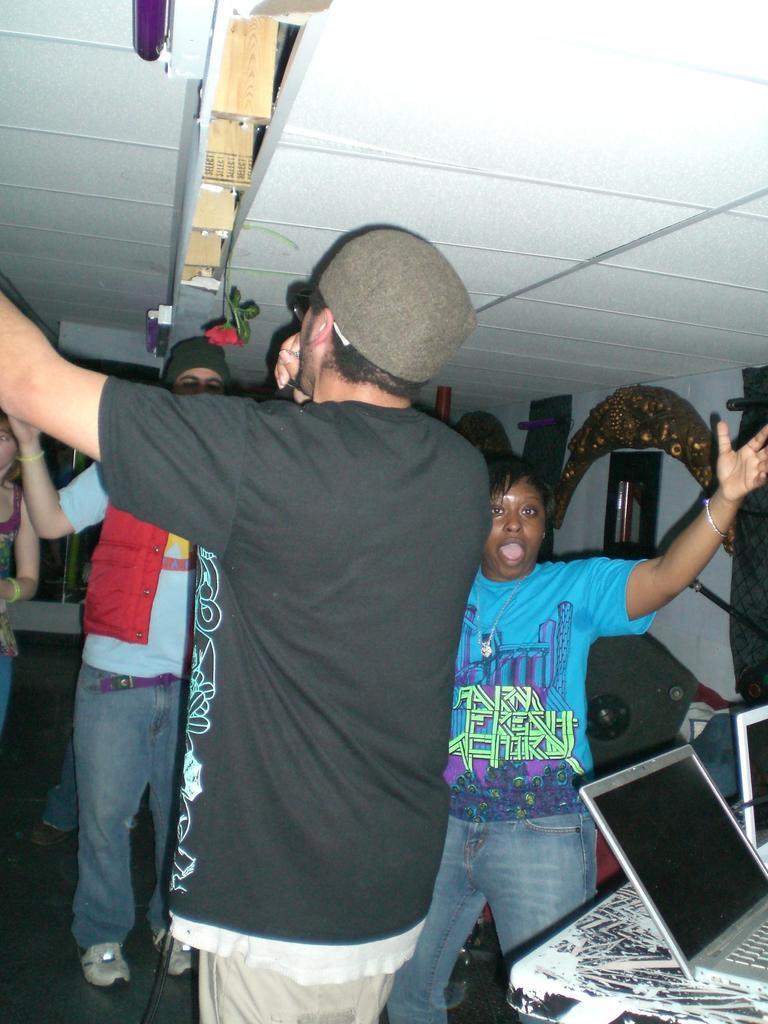Can you describe this image briefly? In this image we can see a few people, on the right side of the image we can see a table with a few laptops on it, at the top of the roof, we can see some objects and also we can see a mirror, stands and other objects on the wall. 